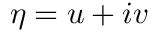<formula> <loc_0><loc_0><loc_500><loc_500>\eta = u + i v</formula> 